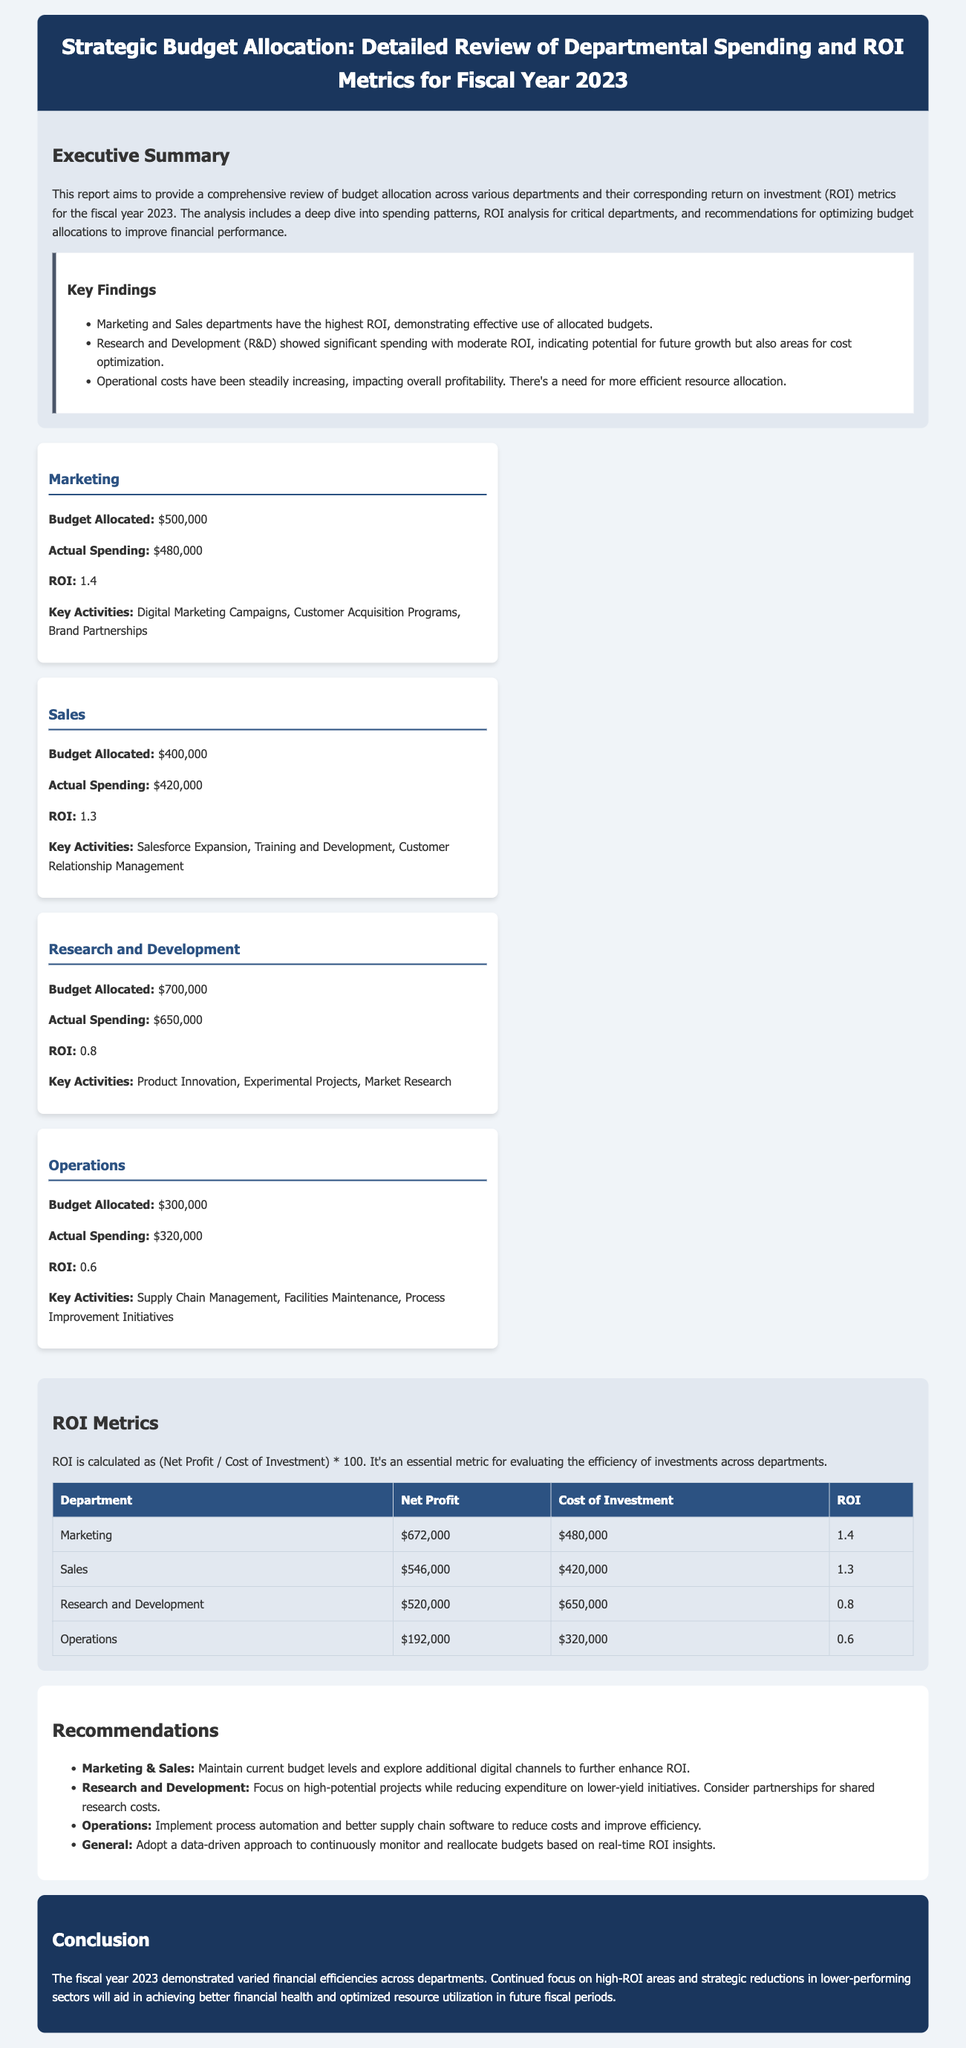What was the total budget allocated for Marketing? The total budget allocated for Marketing is mentioned as $500,000 in the document.
Answer: $500,000 What was the actual spending for Sales? The actual spending for Sales is specified as $420,000.
Answer: $420,000 What is the ROI for Operations? The ROI for Operations is found in the document as 0.6.
Answer: 0.6 Which department showed a significant spending with moderate ROI? The document states that Research and Development (R&D) showed significant spending with moderate ROI.
Answer: Research and Development What is the recommended approach for better budget management? The recommendations section suggests adopting a data-driven approach to continuously monitor and reallocate budgets.
Answer: A data-driven approach Which department had the highest ROI? The report indicates that the Marketing department had the highest ROI of 1.4.
Answer: Marketing What was the net profit for Research and Development? The net profit for Research and Development is listed as $520,000.
Answer: $520,000 What primary activities does the Operations department focus on? The key activities for the Operations department include Supply Chain Management and Facilities Maintenance, among others.
Answer: Supply Chain Management, Facilities Maintenance What does ROI stand for? The document explains that ROI stands for Return on Investment.
Answer: Return on Investment Which department's spending is impacting overall profitability? The document highlights that Operational costs have been steadily increasing, impacting overall profitability.
Answer: Operations 